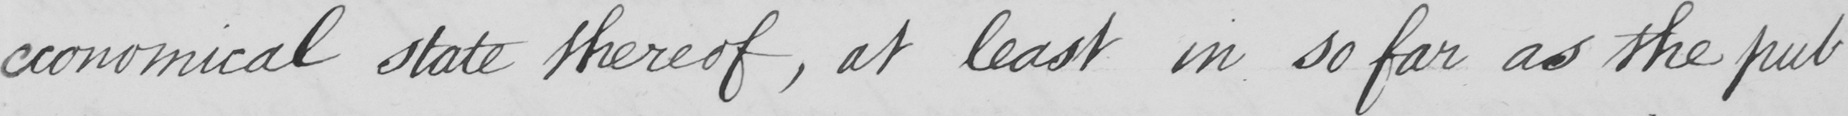Transcribe the text shown in this historical manuscript line. economical state thereof , at least in so far as the pub- 